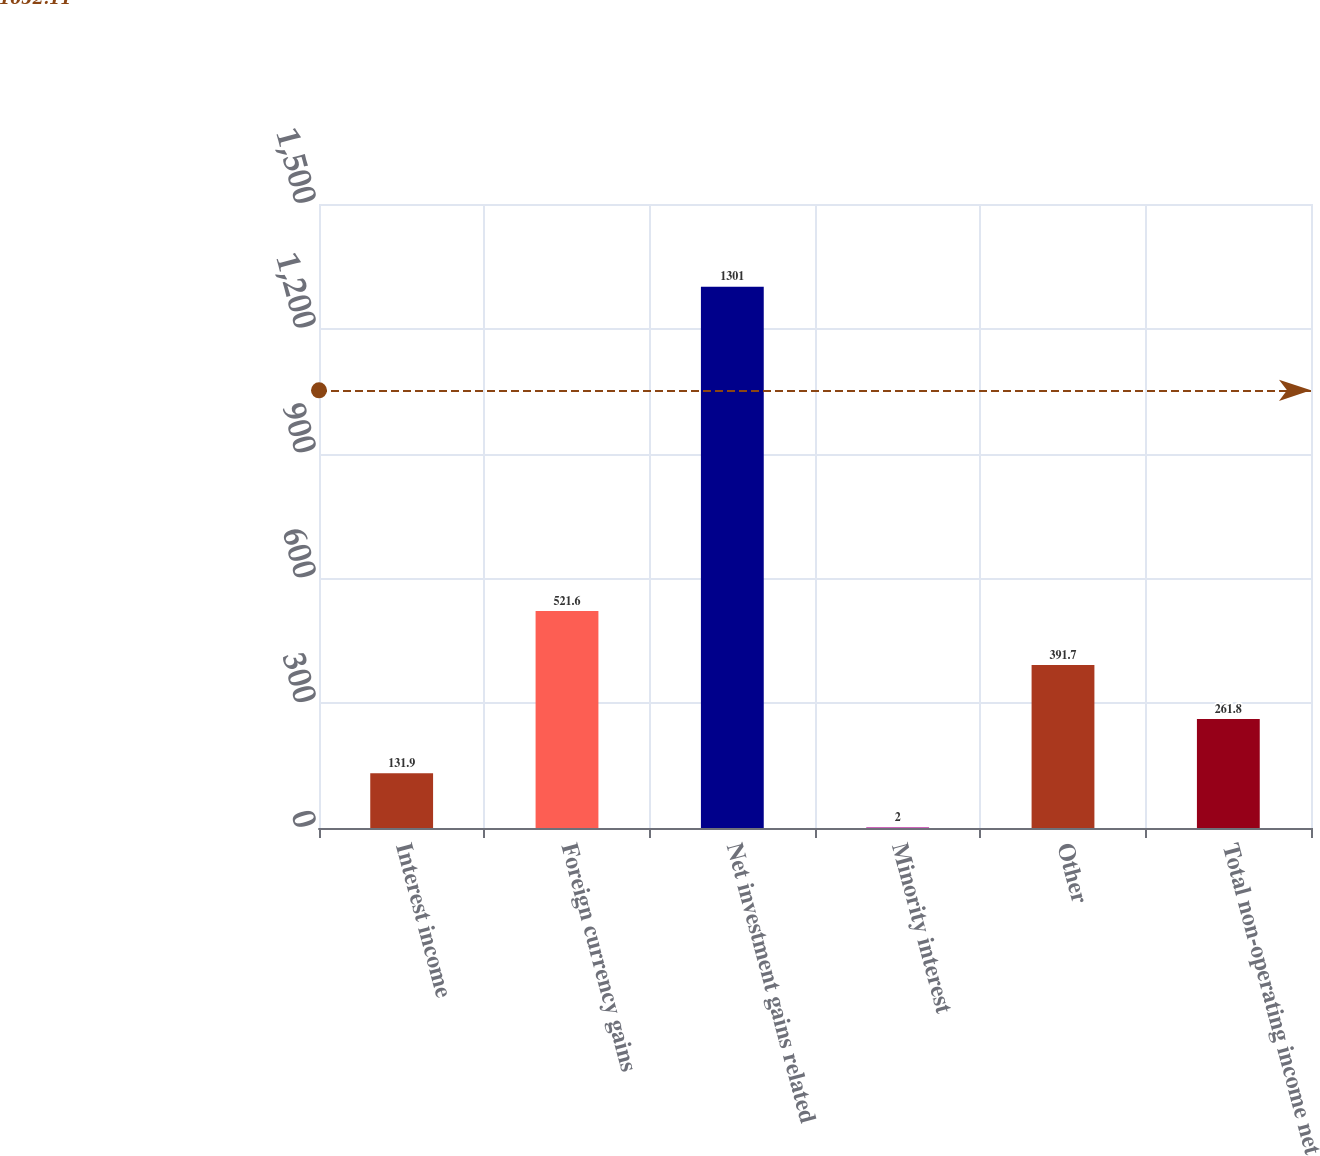Convert chart. <chart><loc_0><loc_0><loc_500><loc_500><bar_chart><fcel>Interest income<fcel>Foreign currency gains<fcel>Net investment gains related<fcel>Minority interest<fcel>Other<fcel>Total non-operating income net<nl><fcel>131.9<fcel>521.6<fcel>1301<fcel>2<fcel>391.7<fcel>261.8<nl></chart> 